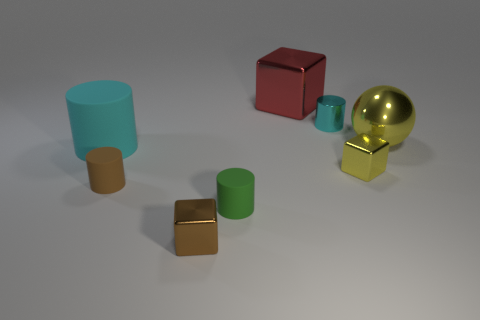Can you describe the lighting in the image? The lighting in the image appears soft and diffuse, providing an even illumination with subtle shadows indicating that the light source is possibly overhead. Does the lighting affect the colors of the objects in any way? The lighting seems to enhance the true colors of the objects without creating harsh highlights or deep shadows, allowing for the colors to appear vibrant and true to their hue. 